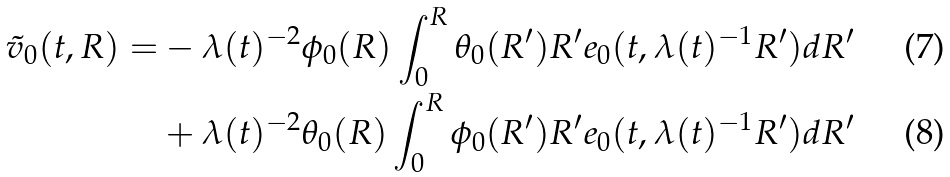<formula> <loc_0><loc_0><loc_500><loc_500>\tilde { v } _ { 0 } ( t , R ) = & - \lambda ( t ) ^ { - 2 } \phi _ { 0 } ( R ) \int _ { 0 } ^ { R } \theta _ { 0 } ( R ^ { \prime } ) R ^ { \prime } e _ { 0 } ( t , \lambda ( t ) ^ { - 1 } R ^ { \prime } ) d R ^ { \prime } \\ & + \lambda ( t ) ^ { - 2 } \theta _ { 0 } ( R ) \int _ { 0 } ^ { R } \phi _ { 0 } ( R ^ { \prime } ) R ^ { \prime } e _ { 0 } ( t , \lambda ( t ) ^ { - 1 } R ^ { \prime } ) d R ^ { \prime }</formula> 